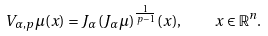<formula> <loc_0><loc_0><loc_500><loc_500>V _ { \alpha , p } \mu ( x ) = J _ { \alpha } ( J _ { \alpha } \mu ) ^ { \frac { 1 } { p - 1 } } ( x ) , \quad x \in \mathbb { R } ^ { n } .</formula> 